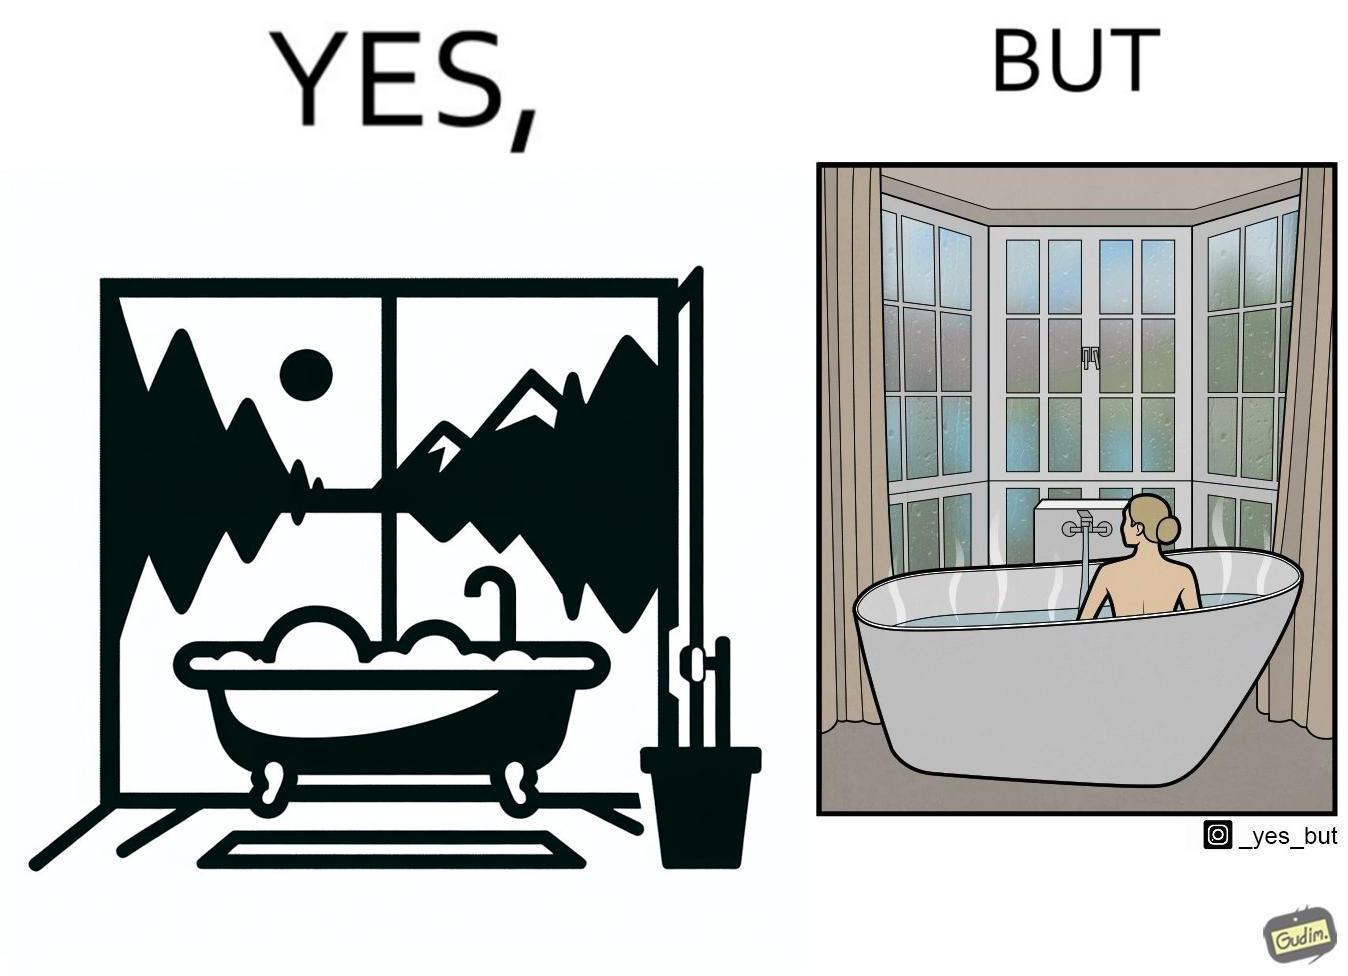Explain the humor or irony in this image. The image is ironical, as a bathtub near a window having a very scenic view, becomes misty when someone is bathing, thus making the scenic view blurry. 